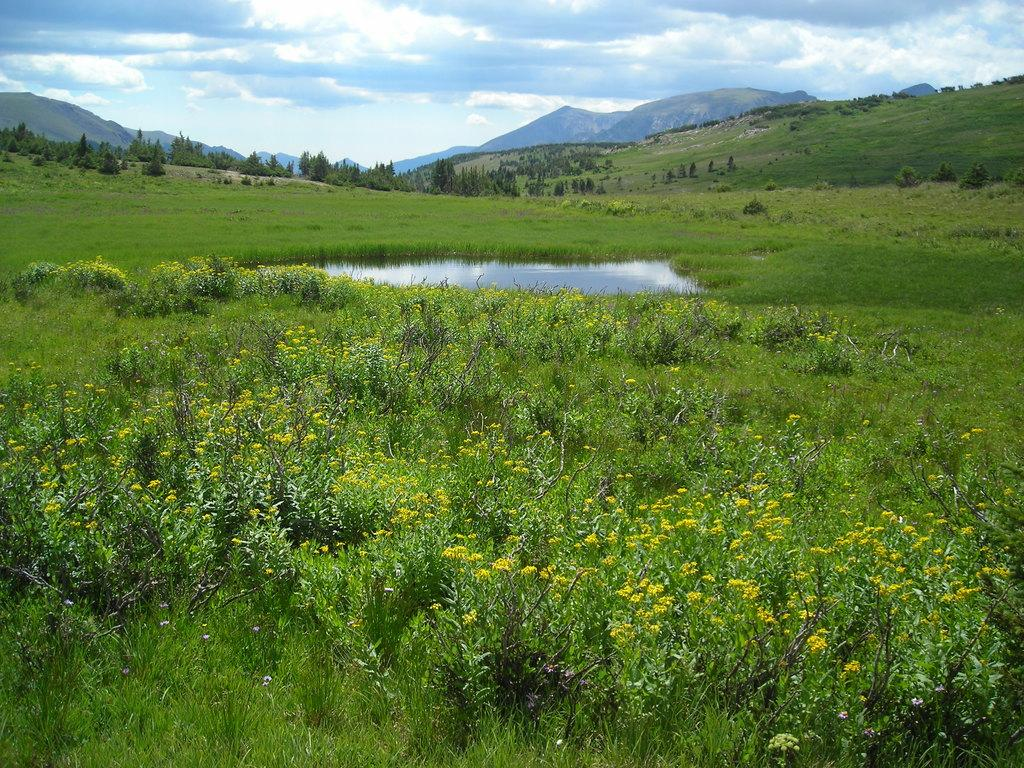What can be seen in the foreground of the image? There are many flower plants in the foreground of the image. What is present in the image besides the flower plants? There is a water body, hills, and trees in the background of the image. How is the sky depicted in the image? The sky is cloudy in the image. How many pieces of lace can be seen in the image? There is no lace present in the image. What type of glass is used to create the water body in the image? The water body in the image is not made of glass; it is a natural body of water. 